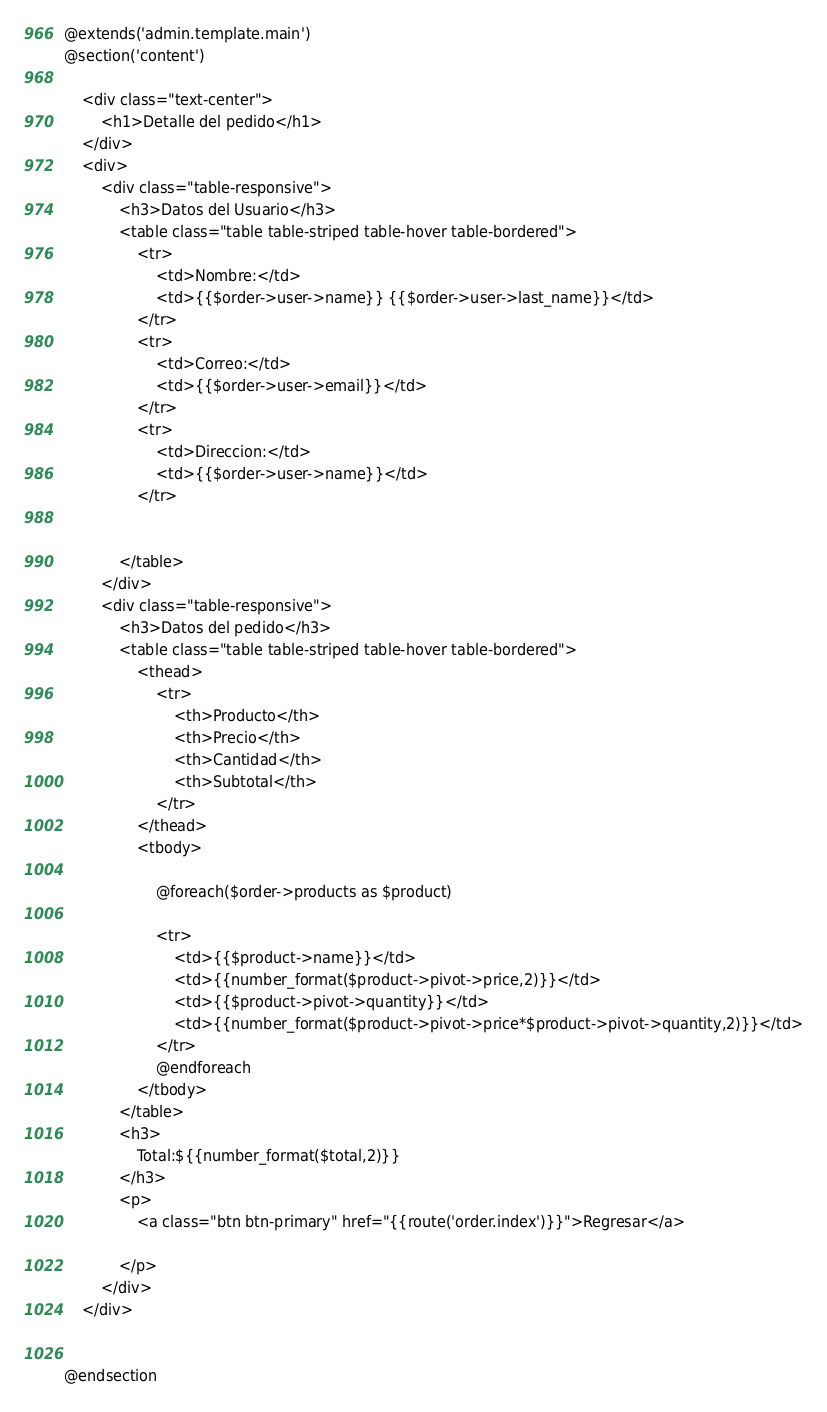<code> <loc_0><loc_0><loc_500><loc_500><_PHP_>@extends('admin.template.main') 
@section('content')

    <div class="text-center">
        <h1>Detalle del pedido</h1>
    </div>
    <div>
        <div class="table-responsive">
            <h3>Datos del Usuario</h3>
            <table class="table table-striped table-hover table-bordered">
                <tr>
                    <td>Nombre:</td>
                    <td>{{$order->user->name}} {{$order->user->last_name}}</td>
                </tr>
                <tr>
                    <td>Correo:</td>
                    <td>{{$order->user->email}}</td>
                </tr>
                <tr>
                    <td>Direccion:</td>
                    <td>{{$order->user->name}}</td>
                </tr>


            </table>
        </div>
        <div class="table-responsive">
            <h3>Datos del pedido</h3>
            <table class="table table-striped table-hover table-bordered">
                <thead>
                    <tr>
                        <th>Producto</th>
                        <th>Precio</th>
                        <th>Cantidad</th>
                        <th>Subtotal</th>
                    </tr>
                </thead>
                <tbody>
                   
                    @foreach($order->products as $product)

                    <tr>
                        <td>{{$product->name}}</td>
                        <td>{{number_format($product->pivot->price,2)}}</td>
                        <td>{{$product->pivot->quantity}}</td>
                        <td>{{number_format($product->pivot->price*$product->pivot->quantity,2)}}</td>
                    </tr>
                    @endforeach
                </tbody>
            </table>
            <h3>
                Total:${{number_format($total,2)}}
            </h3>
            <p>
                <a class="btn btn-primary" href="{{route('order.index')}}">Regresar</a>
                
            </p>
        </div>
    </div>


@endsection</code> 